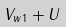Convert formula to latex. <formula><loc_0><loc_0><loc_500><loc_500>V _ { w 1 } + U</formula> 